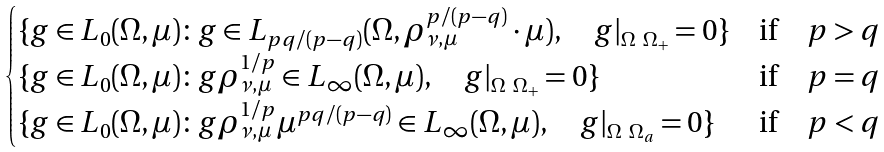<formula> <loc_0><loc_0><loc_500><loc_500>\begin{cases} \{ g \in L _ { 0 } ( \Omega , \mu ) \colon g \in L _ { p q / ( p - q ) } ( \Omega , \rho _ { \nu , \mu } ^ { p / ( p - q ) } \cdot \mu ) , \quad g | _ { \Omega \ \Omega _ { + } } = 0 \} & \text {if} \quad p > q \\ \{ g \in L _ { 0 } ( \Omega , \mu ) \colon g \rho _ { \nu , \mu } ^ { 1 / p } \in L _ { \infty } ( \Omega , \mu ) , \quad g | _ { \Omega \ \Omega _ { + } } = 0 \} & \text {if} \quad p = q \\ \{ g \in L _ { 0 } ( \Omega , \mu ) \colon g \rho _ { \nu , \mu } ^ { 1 / p } \mu ^ { p q / ( p - q ) } \in L _ { \infty } ( \Omega , \mu ) , \quad g | _ { \Omega \ \Omega _ { a } } = 0 \} & \text {if} \quad p < q \\ \end{cases}</formula> 